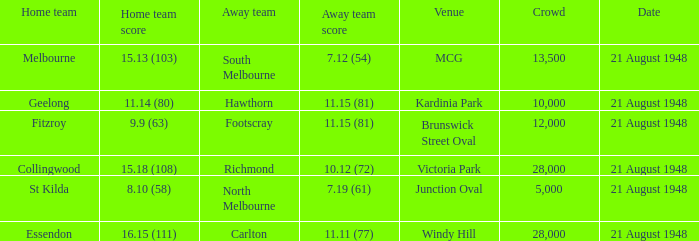When the Away team is south melbourne, what's the Home team score? 15.13 (103). 